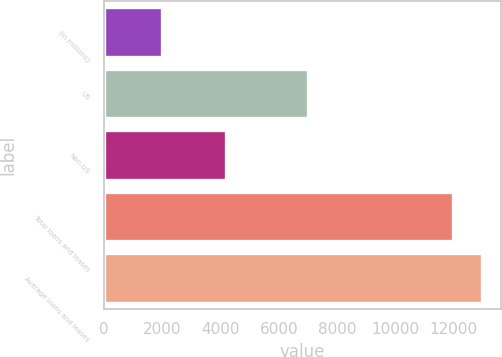Convert chart to OTSL. <chart><loc_0><loc_0><loc_500><loc_500><bar_chart><fcel>(In millions)<fcel>US<fcel>Non-US<fcel>Total loans and leases<fcel>Average loans and leases<nl><fcel>2010<fcel>7001<fcel>4192<fcel>11957<fcel>12965.4<nl></chart> 